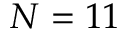Convert formula to latex. <formula><loc_0><loc_0><loc_500><loc_500>N = 1 1</formula> 